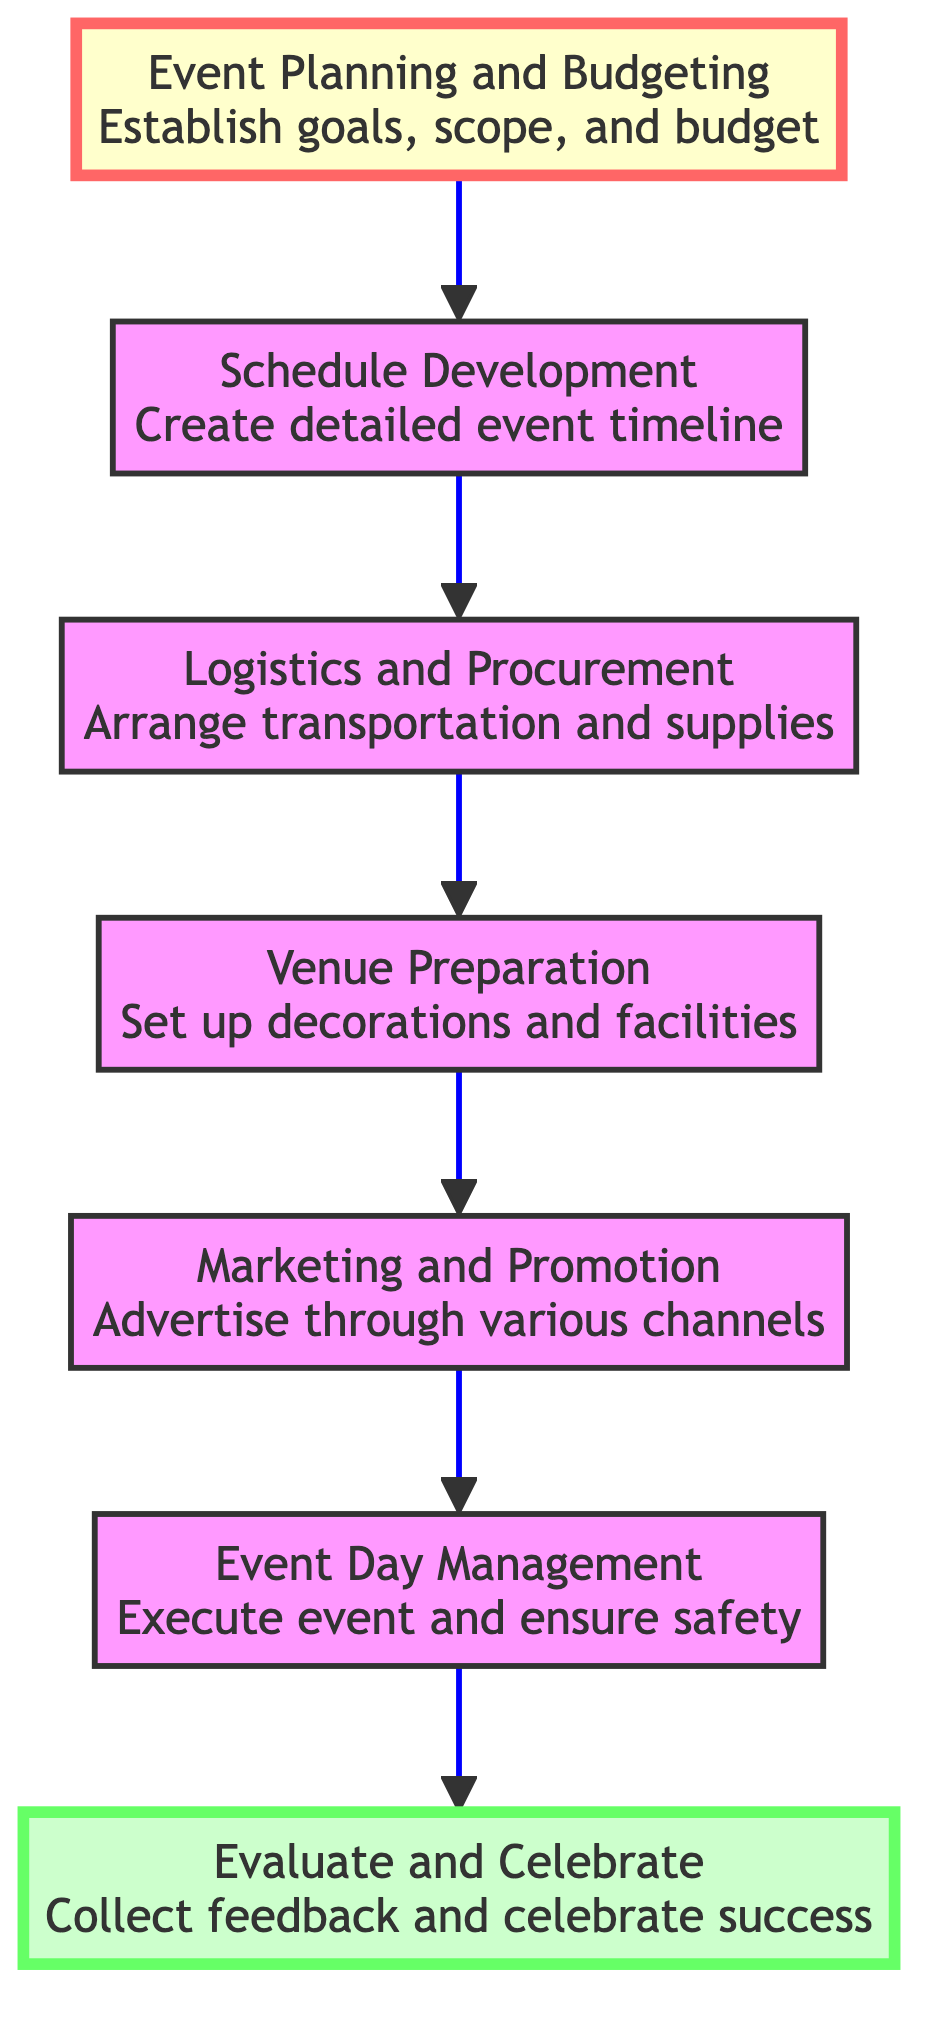What is the first step in organizing the event? The first step listed in the diagram is "Event Planning and Budgeting," which establishes the event goals, scope, and budget.
Answer: Event Planning and Budgeting How many total steps are outlined in the diagram? The diagram outlines a total of seven steps, as indicated by the flow from the initial event planning to the final evaluation.
Answer: 7 What comes after "Logistics and Procurement"? Following "Logistics and Procurement," the next step in the flow is "Venue Preparation." This indicates the sequence of actions that need to be taken in organizing the event.
Answer: Venue Preparation Which step involves advertising the event? The step that specifically involves advertising is "Marketing and Promotion," as it focuses on promoting the event through various channels.
Answer: Marketing and Promotion What is the last step in the process? The last step, representing the culmination of the event organization process, is "Evaluate and Celebrate," which involves gathering feedback and celebrating success.
Answer: Evaluate and Celebrate If the event day management is not successful, which step would be most directly impacted? If "Event Day Management" is not successful, it would most directly affect the "Evaluate and Celebrate" step, as the feedback collected might reflect issues from the event day execution.
Answer: Evaluate and Celebrate Which step comes directly before "Evaluate and Celebrate"? "Event Day Management" comes directly before "Evaluate and Celebrate," indicating that the management of the event is completed before evaluating its success.
Answer: Event Day Management What type of activities are planned during the "Schedule Development" step? The "Schedule Development" step entails creating a detailed event timeline that includes timings for sporting activities such as sumo matches, awards ceremonies, and traditional performances.
Answer: Sporting activities How is "Marketing and Promotion" related to "Event Day Management"? "Marketing and Promotion" is related to "Event Day Management" because effective marketing is essential for ensuring a good turnout on the event day, thus impacting its success.
Answer: Effective turnout 